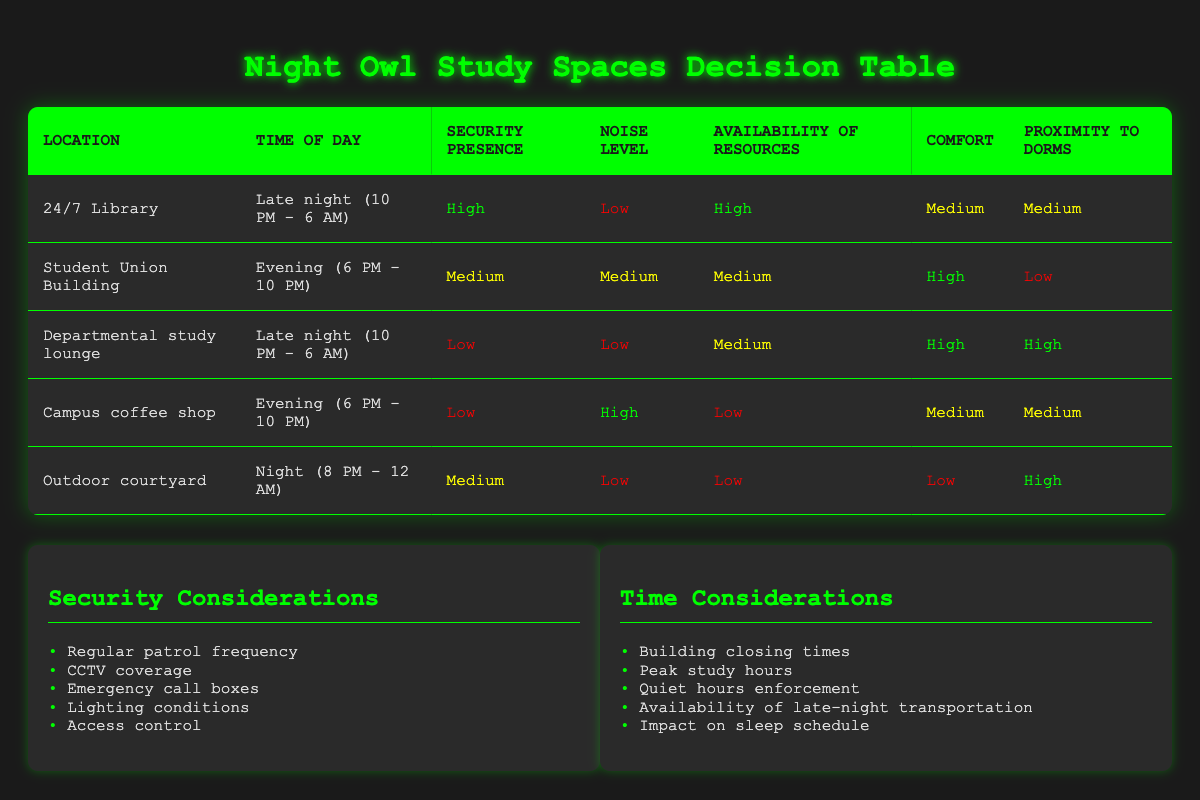What is the security presence level at the 24/7 Library? According to the table, the 24/7 Library has a security presence marked as "High." This information is directly taken from the corresponding row in the table for this specific location.
Answer: High Which location has the lowest noise level during late night hours? The Departmental study lounge and 24/7 Library are both during late night hours and have low noise levels. However, the Departmental study lounge has a higher comfort rating, which may be a preference for some students.
Answer: Departmental study lounge Is there a location available for late-night studying that offers high availability of resources? Yes, the 24/7 Library is the only location that offers high availability of resources during late night hours. This is evident from the table where it states this rating for the specific location.
Answer: Yes What is the average comfort level rating of all locations? The comfort levels for the locations are Medium (2), High (3), and Low (2). To calculate the average, assign numeric values: Low = 1, Medium = 2, High = 3. The sum is 2+3+2+2+1=10. There are 5 locations, so the average is 10/5=2.
Answer: 2 Is the Student Union Building quieter than the Campus coffee shop during the evening? Yes, the Student Union Building has a medium noise level while the Campus coffee shop has a high noise level. This clear comparison between noise levels indicates that the Student Union is quieter.
Answer: Yes Which study space is closest to the dorms and has low security presence during late-night hours? The Departmental study lounge is closest to the dorms with a high proximity rating but has a low security presence. This conclusion is drawn from examining both the proximity and security presence fields in the table for late-night hours.
Answer: Departmental study lounge How many locations have medium security presence during night hours? The Outdoor courtyard has a medium security presence. By reviewing the various locations, only this one meets the criteria of being during night hours and having medium security presence.
Answer: 1 Which location has the highest comfort rating but low proximity to dorms? The Student Union Building has the highest comfort rating of "High" but the lowest proximity rating of "Low." This is determined by checking the comfort and proximity ratings in the table for each location.
Answer: Student Union Building 